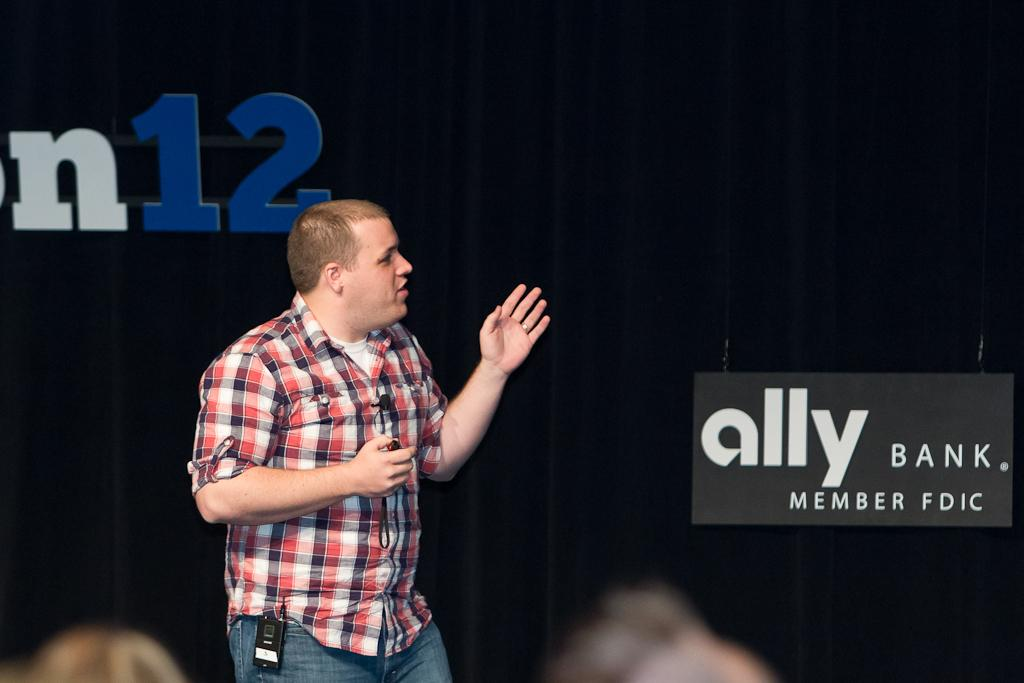Who is the main subject in the image? There is a man in the image. What is the man doing in the image? The man is explaining something. What can be seen behind the man? There are boards and a curtain behind the man. What are the two blurred objects at the bottom of the image? The two blurred objects at the bottom of the image cannot be identified with certainty. What type of instrument is the man playing in the image? The man is not playing any instrument in the image; he is explaining something. Can you tell me which key the man is holding in the image? There is no key visible in the image. 